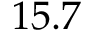<formula> <loc_0><loc_0><loc_500><loc_500>1 5 . 7</formula> 